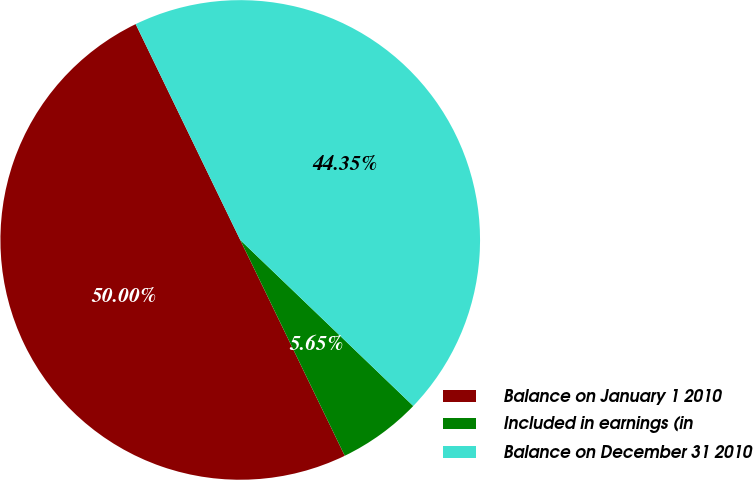Convert chart. <chart><loc_0><loc_0><loc_500><loc_500><pie_chart><fcel>Balance on January 1 2010<fcel>Included in earnings (in<fcel>Balance on December 31 2010<nl><fcel>50.0%<fcel>5.65%<fcel>44.35%<nl></chart> 